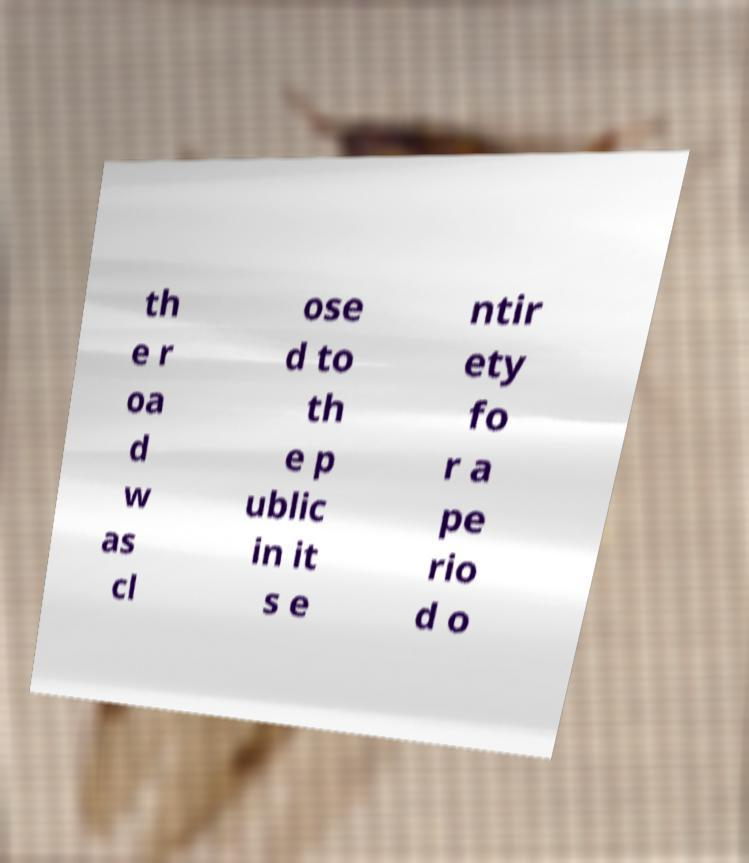There's text embedded in this image that I need extracted. Can you transcribe it verbatim? th e r oa d w as cl ose d to th e p ublic in it s e ntir ety fo r a pe rio d o 